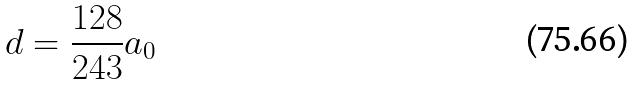<formula> <loc_0><loc_0><loc_500><loc_500>d = \frac { 1 2 8 } { 2 4 3 } a _ { 0 }</formula> 